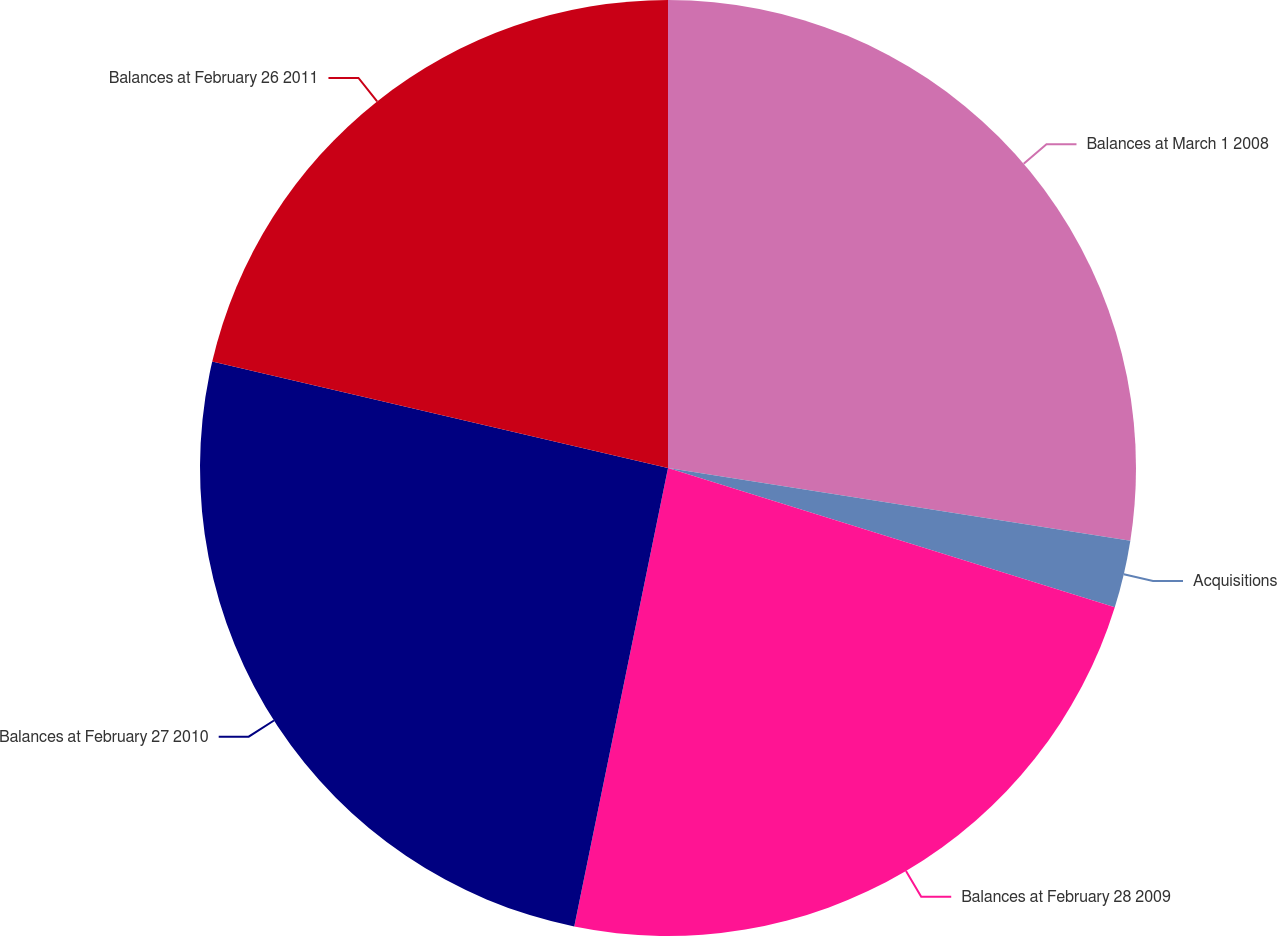Convert chart to OTSL. <chart><loc_0><loc_0><loc_500><loc_500><pie_chart><fcel>Balances at March 1 2008<fcel>Acquisitions<fcel>Balances at February 28 2009<fcel>Balances at February 27 2010<fcel>Balances at February 26 2011<nl><fcel>27.48%<fcel>2.33%<fcel>23.4%<fcel>25.44%<fcel>21.35%<nl></chart> 